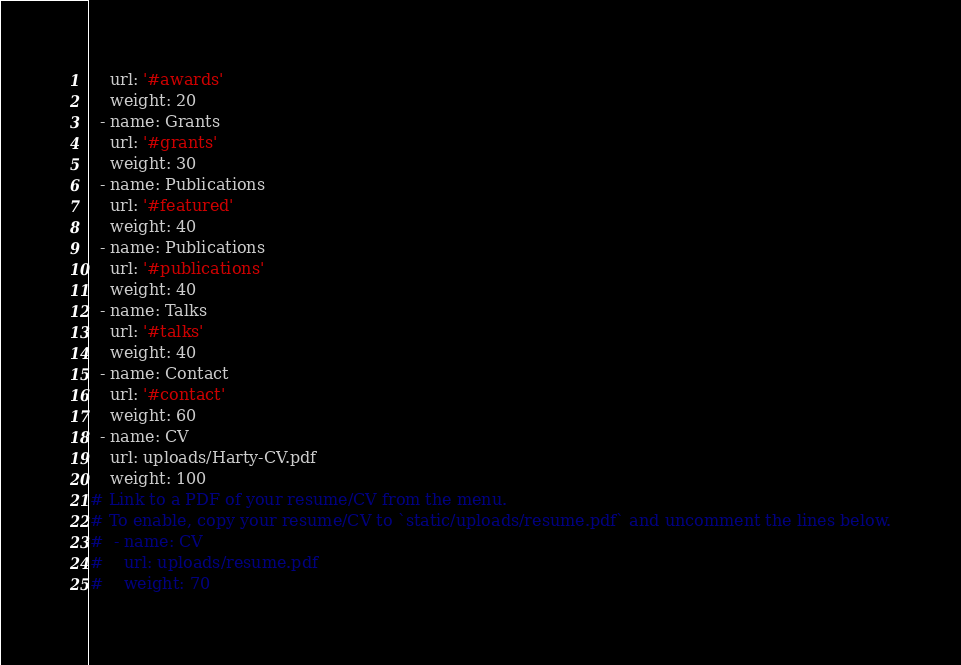<code> <loc_0><loc_0><loc_500><loc_500><_YAML_>    url: '#awards'
    weight: 20
  - name: Grants
    url: '#grants'
    weight: 30
  - name: Publications
    url: '#featured'
    weight: 40
  - name: Publications
    url: '#publications'
    weight: 40
  - name: Talks
    url: '#talks'
    weight: 40
  - name: Contact
    url: '#contact'
    weight: 60
  - name: CV
    url: uploads/Harty-CV.pdf
    weight: 100
# Link to a PDF of your resume/CV from the menu.
# To enable, copy your resume/CV to `static/uploads/resume.pdf` and uncomment the lines below.
#  - name: CV
#    url: uploads/resume.pdf
#    weight: 70
</code> 